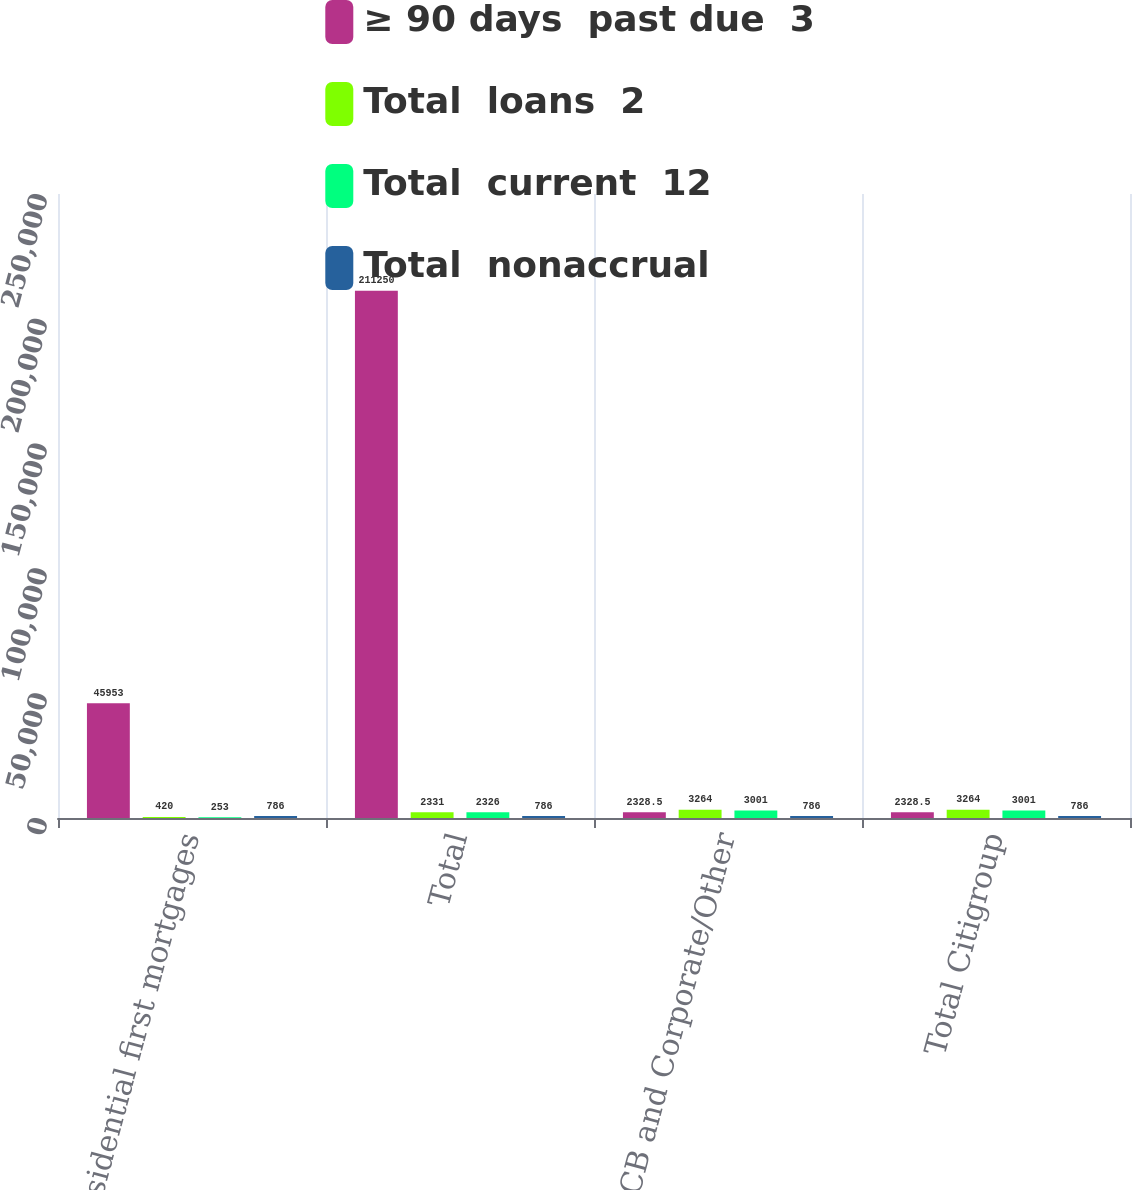<chart> <loc_0><loc_0><loc_500><loc_500><stacked_bar_chart><ecel><fcel>Residential first mortgages<fcel>Total<fcel>Total GCB and Corporate/Other<fcel>Total Citigroup<nl><fcel>≥ 90 days  past due  3<fcel>45953<fcel>211250<fcel>2328.5<fcel>2328.5<nl><fcel>Total  loans  2<fcel>420<fcel>2331<fcel>3264<fcel>3264<nl><fcel>Total  current  12<fcel>253<fcel>2326<fcel>3001<fcel>3001<nl><fcel>Total  nonaccrual<fcel>786<fcel>786<fcel>786<fcel>786<nl></chart> 